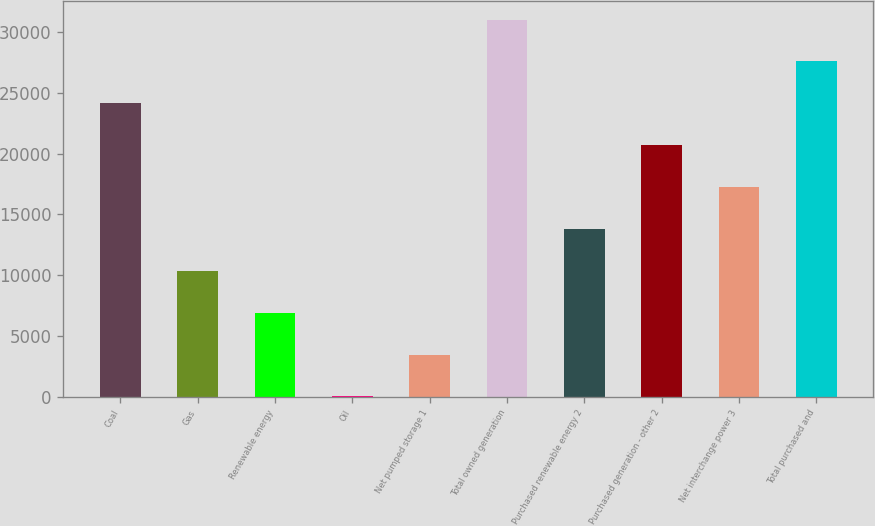Convert chart to OTSL. <chart><loc_0><loc_0><loc_500><loc_500><bar_chart><fcel>Coal<fcel>Gas<fcel>Renewable energy<fcel>Oil<fcel>Net pumped storage 1<fcel>Total owned generation<fcel>Purchased renewable energy 2<fcel>Purchased generation - other 2<fcel>Net interchange power 3<fcel>Total purchased and<nl><fcel>24137.2<fcel>10346.8<fcel>6899.2<fcel>4<fcel>3451.6<fcel>31032.4<fcel>13794.4<fcel>20689.6<fcel>17242<fcel>27584.8<nl></chart> 